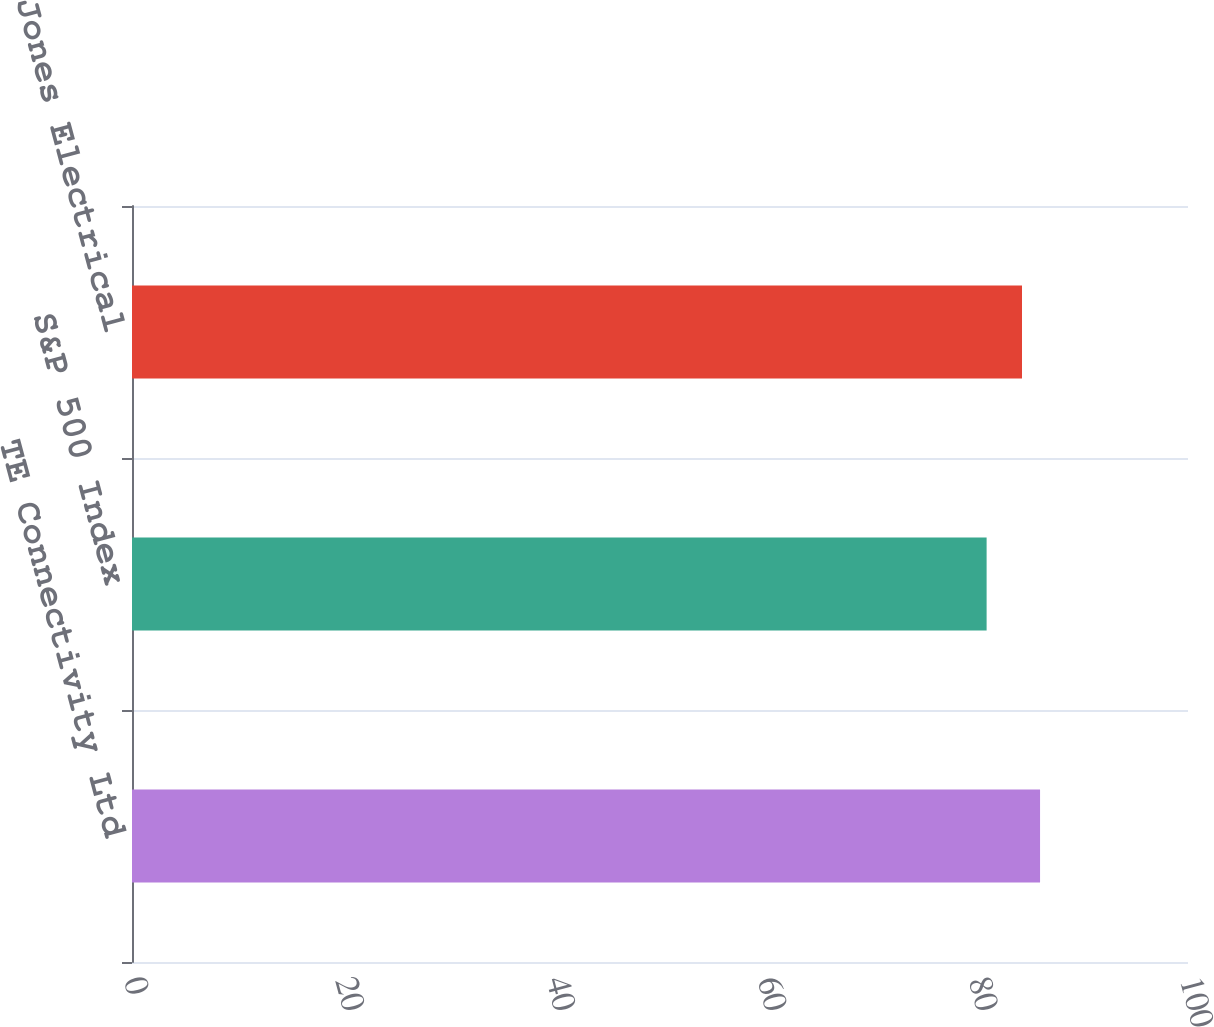Convert chart to OTSL. <chart><loc_0><loc_0><loc_500><loc_500><bar_chart><fcel>TE Connectivity Ltd<fcel>S&P 500 Index<fcel>Dow Jones Electrical<nl><fcel>85.99<fcel>80.93<fcel>84.28<nl></chart> 